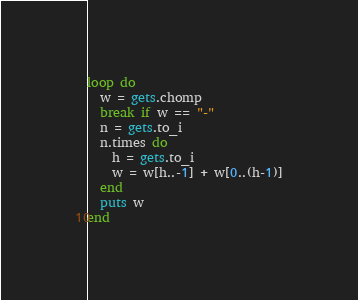<code> <loc_0><loc_0><loc_500><loc_500><_Ruby_>loop do
  w = gets.chomp
  break if w == "-"
  n = gets.to_i
  n.times do
    h = gets.to_i
    w = w[h..-1] + w[0..(h-1)]
  end
  puts w
end

</code> 